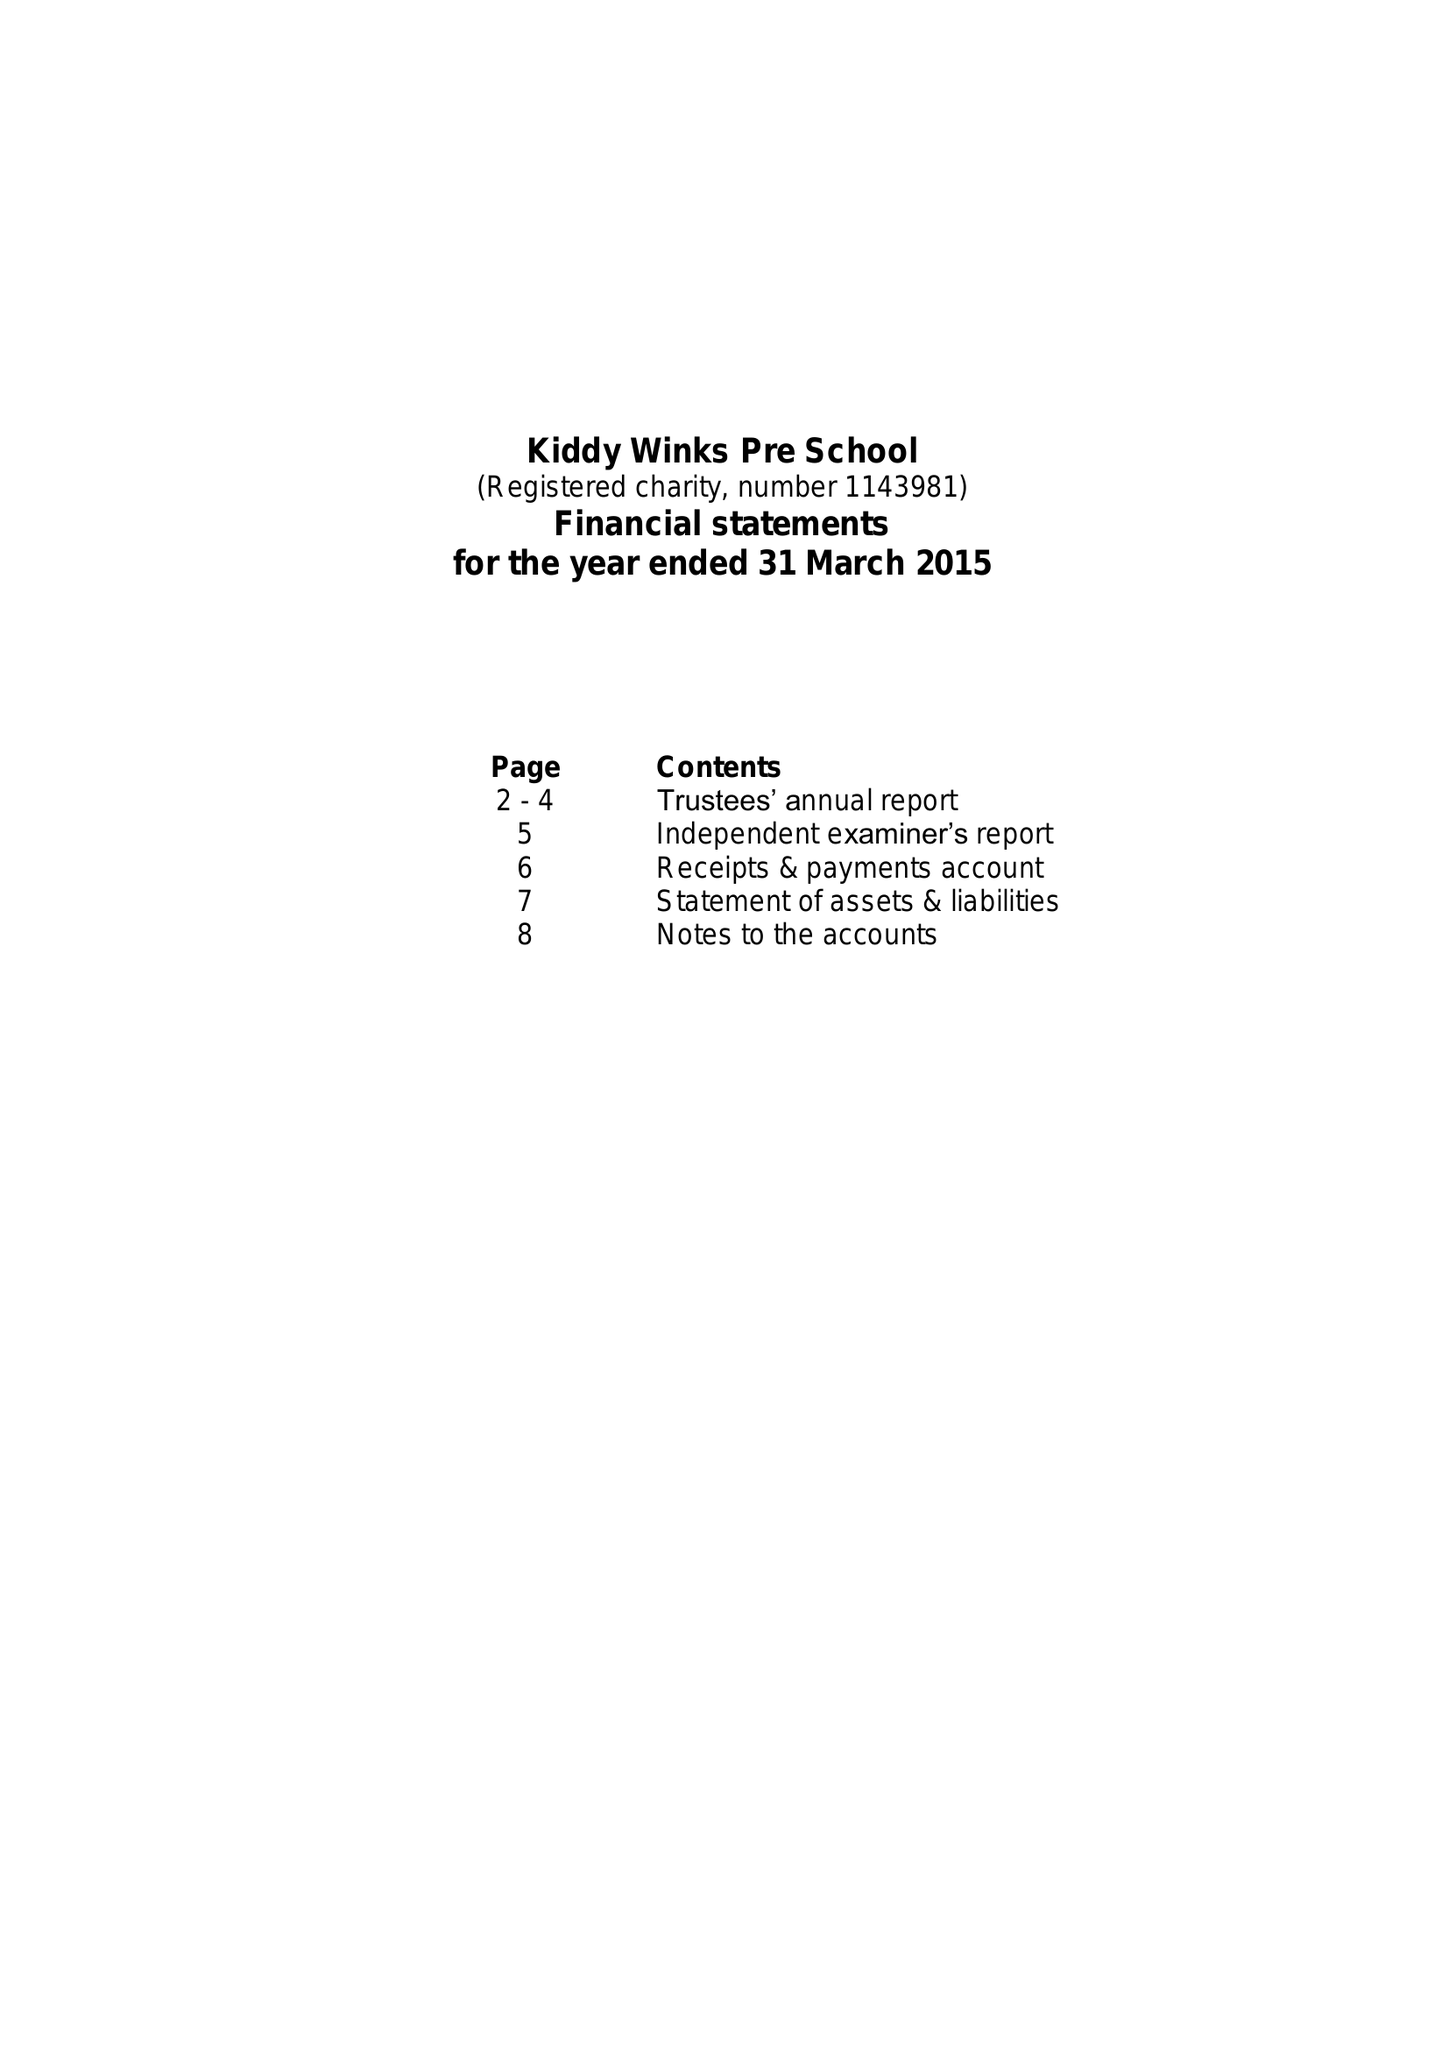What is the value for the income_annually_in_british_pounds?
Answer the question using a single word or phrase. 90095.00 